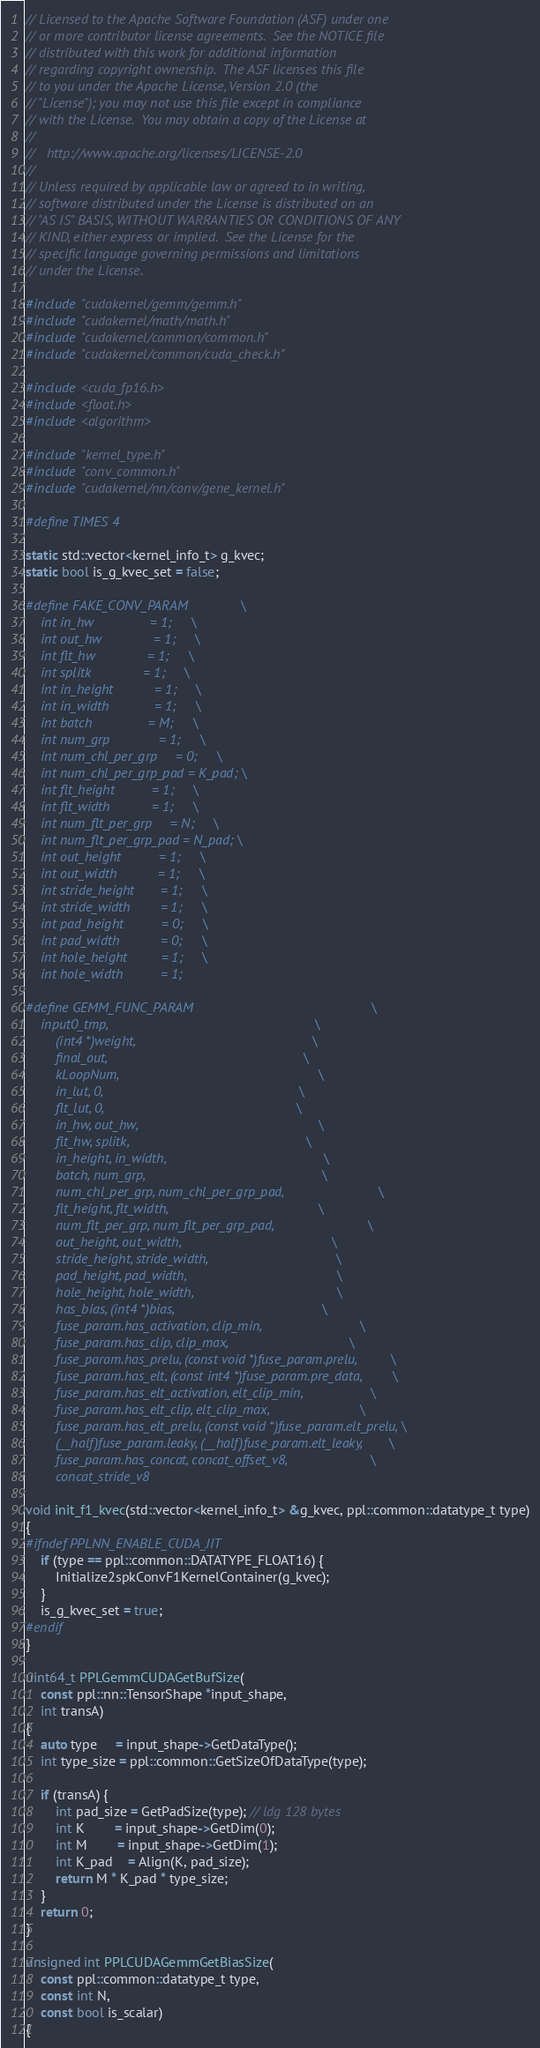<code> <loc_0><loc_0><loc_500><loc_500><_Cuda_>// Licensed to the Apache Software Foundation (ASF) under one
// or more contributor license agreements.  See the NOTICE file
// distributed with this work for additional information
// regarding copyright ownership.  The ASF licenses this file
// to you under the Apache License, Version 2.0 (the
// "License"); you may not use this file except in compliance
// with the License.  You may obtain a copy of the License at
//
//   http://www.apache.org/licenses/LICENSE-2.0
//
// Unless required by applicable law or agreed to in writing,
// software distributed under the License is distributed on an
// "AS IS" BASIS, WITHOUT WARRANTIES OR CONDITIONS OF ANY
// KIND, either express or implied.  See the License for the
// specific language governing permissions and limitations
// under the License.

#include "cudakernel/gemm/gemm.h"
#include "cudakernel/math/math.h"
#include "cudakernel/common/common.h"
#include "cudakernel/common/cuda_check.h"

#include <cuda_fp16.h>
#include <float.h>
#include <algorithm>

#include "kernel_type.h"
#include "conv_common.h"
#include "cudakernel/nn/conv/gene_kernel.h"

#define TIMES 4

static std::vector<kernel_info_t> g_kvec;
static bool is_g_kvec_set = false;

#define FAKE_CONV_PARAM              \
    int in_hw               = 1;     \
    int out_hw              = 1;     \
    int flt_hw              = 1;     \
    int splitk              = 1;     \
    int in_height           = 1;     \
    int in_width            = 1;     \
    int batch               = M;     \
    int num_grp             = 1;     \
    int num_chl_per_grp     = 0;     \
    int num_chl_per_grp_pad = K_pad; \
    int flt_height          = 1;     \
    int flt_width           = 1;     \
    int num_flt_per_grp     = N;     \
    int num_flt_per_grp_pad = N_pad; \
    int out_height          = 1;     \
    int out_width           = 1;     \
    int stride_height       = 1;     \
    int stride_width        = 1;     \
    int pad_height          = 0;     \
    int pad_width           = 0;     \
    int hole_height         = 1;     \
    int hole_width          = 1;

#define GEMM_FUNC_PARAM                                               \
    input0_tmp,                                                       \
        (int4 *)weight,                                               \
        final_out,                                                    \
        kLoopNum,                                                     \
        in_lut, 0,                                                    \
        flt_lut, 0,                                                   \
        in_hw, out_hw,                                                \
        flt_hw, splitk,                                               \
        in_height, in_width,                                          \
        batch, num_grp,                                               \
        num_chl_per_grp, num_chl_per_grp_pad,                         \
        flt_height, flt_width,                                        \
        num_flt_per_grp, num_flt_per_grp_pad,                         \
        out_height, out_width,                                        \
        stride_height, stride_width,                                  \
        pad_height, pad_width,                                        \
        hole_height, hole_width,                                      \
        has_bias, (int4 *)bias,                                       \
        fuse_param.has_activation, clip_min,                          \
        fuse_param.has_clip, clip_max,                                \
        fuse_param.has_prelu, (const void *)fuse_param.prelu,         \
        fuse_param.has_elt, (const int4 *)fuse_param.pre_data,        \
        fuse_param.has_elt_activation, elt_clip_min,                  \
        fuse_param.has_elt_clip, elt_clip_max,                        \
        fuse_param.has_elt_prelu, (const void *)fuse_param.elt_prelu, \
        (__half)fuse_param.leaky, (__half)fuse_param.elt_leaky,       \
        fuse_param.has_concat, concat_offset_v8,                      \
        concat_stride_v8

void init_f1_kvec(std::vector<kernel_info_t> &g_kvec, ppl::common::datatype_t type)
{
#ifndef PPLNN_ENABLE_CUDA_JIT
    if (type == ppl::common::DATATYPE_FLOAT16) {
        Initialize2spkConvF1KernelContainer(g_kvec);
    }
    is_g_kvec_set = true;
#endif
}

uint64_t PPLGemmCUDAGetBufSize(
    const ppl::nn::TensorShape *input_shape,
    int transA)
{
    auto type     = input_shape->GetDataType();
    int type_size = ppl::common::GetSizeOfDataType(type);

    if (transA) {
        int pad_size = GetPadSize(type); // ldg 128 bytes
        int K        = input_shape->GetDim(0);
        int M        = input_shape->GetDim(1);
        int K_pad    = Align(K, pad_size);
        return M * K_pad * type_size;
    }
    return 0;
}

unsigned int PPLCUDAGemmGetBiasSize(
    const ppl::common::datatype_t type,
    const int N,
    const bool is_scalar)
{</code> 